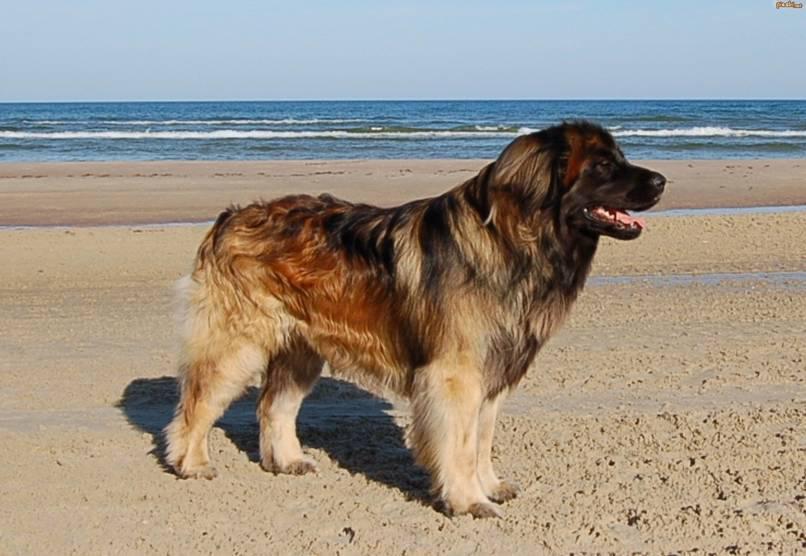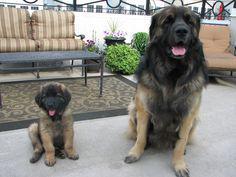The first image is the image on the left, the second image is the image on the right. For the images displayed, is the sentence "A dog is hugging a human in one of the images." factually correct? Answer yes or no. No. The first image is the image on the left, the second image is the image on the right. For the images displayed, is the sentence "A person stands face-to-face with arms around a big standing dog." factually correct? Answer yes or no. No. 